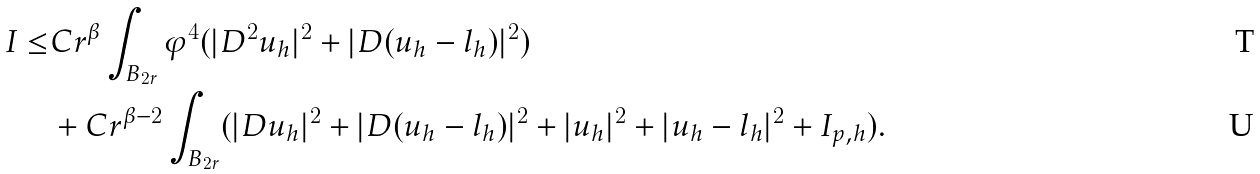Convert formula to latex. <formula><loc_0><loc_0><loc_500><loc_500>I \leq & C r ^ { \beta } \int _ { B _ { 2 r } } \varphi ^ { 4 } ( | D ^ { 2 } u _ { h } | ^ { 2 } + | D ( u _ { h } - l _ { h } ) | ^ { 2 } ) \\ & + C r ^ { \beta - 2 } \int _ { B _ { 2 r } } ( | D u _ { h } | ^ { 2 } + | D ( u _ { h } - l _ { h } ) | ^ { 2 } + | u _ { h } | ^ { 2 } + | u _ { h } - l _ { h } | ^ { 2 } + I _ { p , h } ) .</formula> 